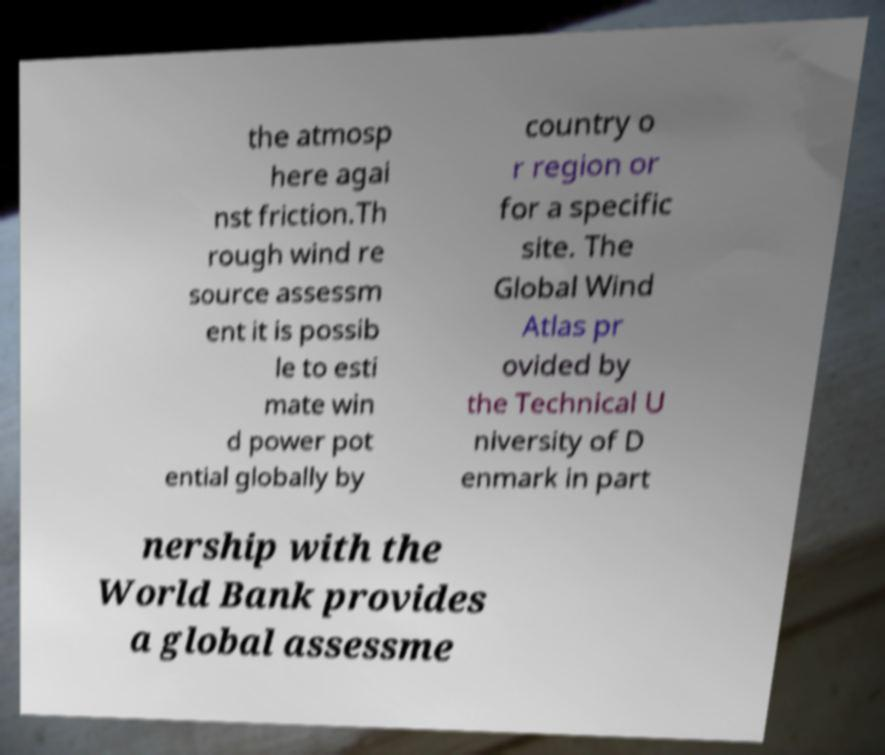Please read and relay the text visible in this image. What does it say? the atmosp here agai nst friction.Th rough wind re source assessm ent it is possib le to esti mate win d power pot ential globally by country o r region or for a specific site. The Global Wind Atlas pr ovided by the Technical U niversity of D enmark in part nership with the World Bank provides a global assessme 